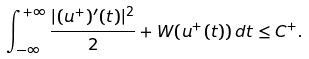<formula> <loc_0><loc_0><loc_500><loc_500>\int _ { - \infty } ^ { + \infty } \frac { | ( u ^ { + } ) ^ { \prime } ( t ) | ^ { 2 } } { 2 } + W ( u ^ { + } ( t ) ) \, d t \leq C ^ { + } .</formula> 